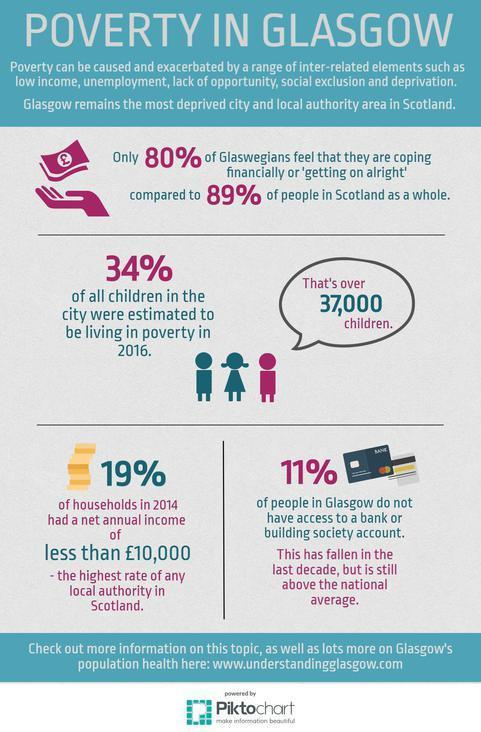How many children in Glasgow were estimated to be living in poverty in 2016?
Answer the question with a short phrase. over 37,000 What percent of people have some access to bank or building society account? 89% 